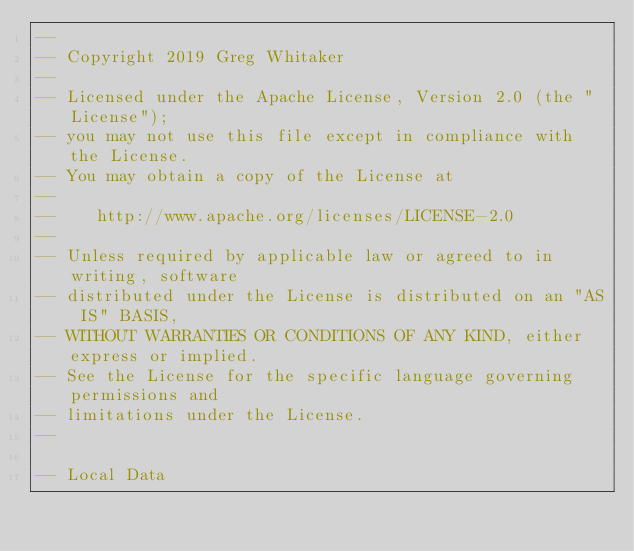<code> <loc_0><loc_0><loc_500><loc_500><_SQL_>--
-- Copyright 2019 Greg Whitaker
--
-- Licensed under the Apache License, Version 2.0 (the "License");
-- you may not use this file except in compliance with the License.
-- You may obtain a copy of the License at
--
--    http://www.apache.org/licenses/LICENSE-2.0
--
-- Unless required by applicable law or agreed to in writing, software
-- distributed under the License is distributed on an "AS IS" BASIS,
-- WITHOUT WARRANTIES OR CONDITIONS OF ANY KIND, either express or implied.
-- See the License for the specific language governing permissions and
-- limitations under the License.
--

-- Local Data</code> 